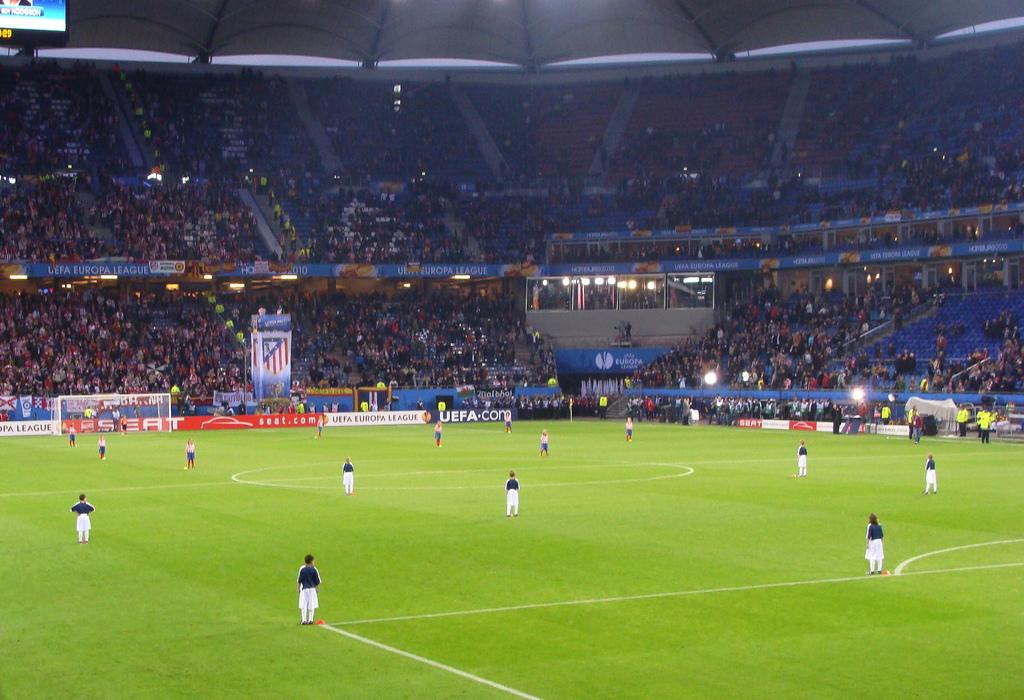What are the people in the image doing? The people in the image are standing on the ground. What can be seen on the walls in the image? There are posters visible from left to right in the image. What is visible in the background of the image? There is a crowd in the background of the image. Where is the screen located in the image? The screen is present in the top left corner of the image. Can you tell me how many people are swimming in the image? There is no swimming activity depicted in the image; the people are standing on the ground. What type of hope is being expressed by the crowd in the image? The image does not convey any specific emotions or expressions of hope; it simply shows a crowd in the background. 